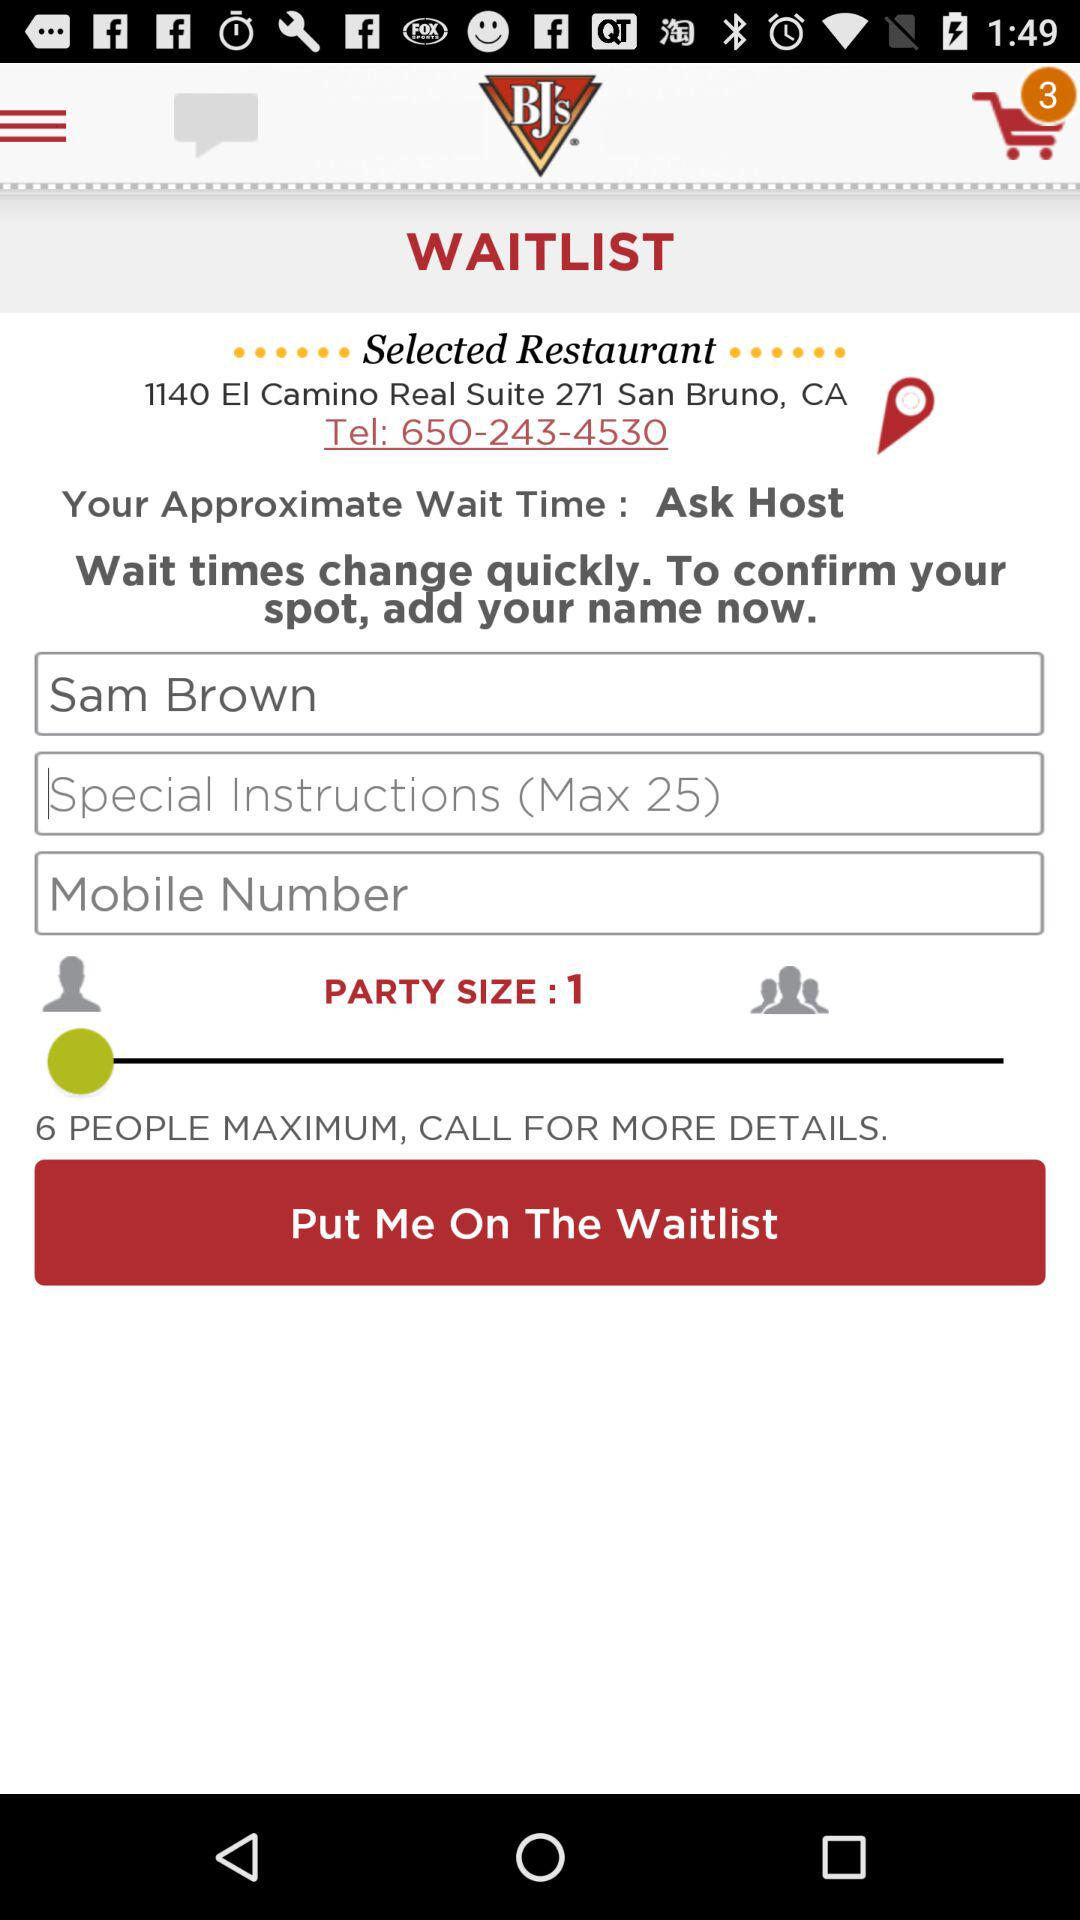What is the address of the selected restaurant? The address is 1140 EI Camino Real, Suite 271, San Bruno, CA. 